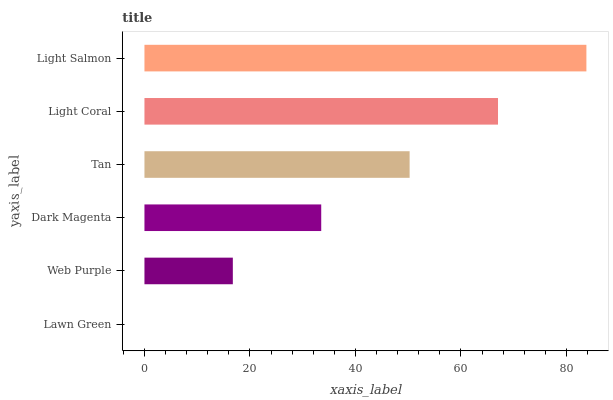Is Lawn Green the minimum?
Answer yes or no. Yes. Is Light Salmon the maximum?
Answer yes or no. Yes. Is Web Purple the minimum?
Answer yes or no. No. Is Web Purple the maximum?
Answer yes or no. No. Is Web Purple greater than Lawn Green?
Answer yes or no. Yes. Is Lawn Green less than Web Purple?
Answer yes or no. Yes. Is Lawn Green greater than Web Purple?
Answer yes or no. No. Is Web Purple less than Lawn Green?
Answer yes or no. No. Is Tan the high median?
Answer yes or no. Yes. Is Dark Magenta the low median?
Answer yes or no. Yes. Is Web Purple the high median?
Answer yes or no. No. Is Lawn Green the low median?
Answer yes or no. No. 